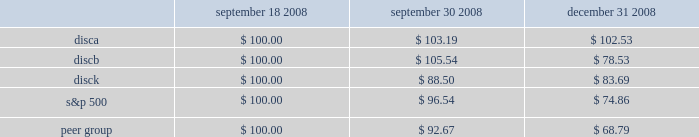2 0 0 8 a n n u a l r e p o r t stock performance graph the following graph sets forth the performance of our series a common , series b common stock , and series c common stock for the period september 18 , 2008 through december 31 , 2008 as compared with the performance of the standard and poor 2019s 500 index and a peer group index which consists of the walt disney company , time warner inc. , cbs corporation class b common stock , viacom , inc .
Class b common stock , news corporation class a common stock , and scripps network interactive , inc .
The graph assumes $ 100 originally invested on september 18 , 2006 and that all subsequent dividends were reinvested in additional shares .
September 18 , september 30 , december 31 , 2008 2008 2008 .
S&p 500 peer group .
What was the percentage cumulative total shareholder return on discb common stock from september 18 , 2008 to december 31 , 2008? 
Computations: ((78.53 - 100) / 100)
Answer: -0.2147. 